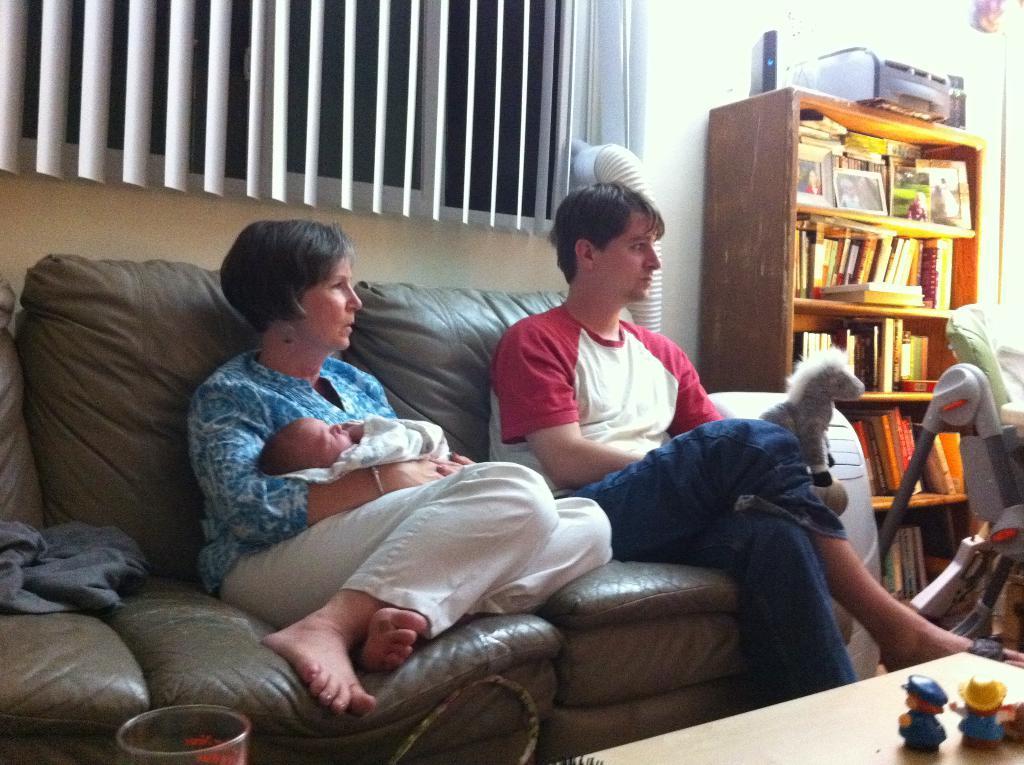Describe this image in one or two sentences. in this image the two persons and one baby they are sitting in the chair in this there are so many things like table,rack and some books in rack again many books and behind the person the window is there 